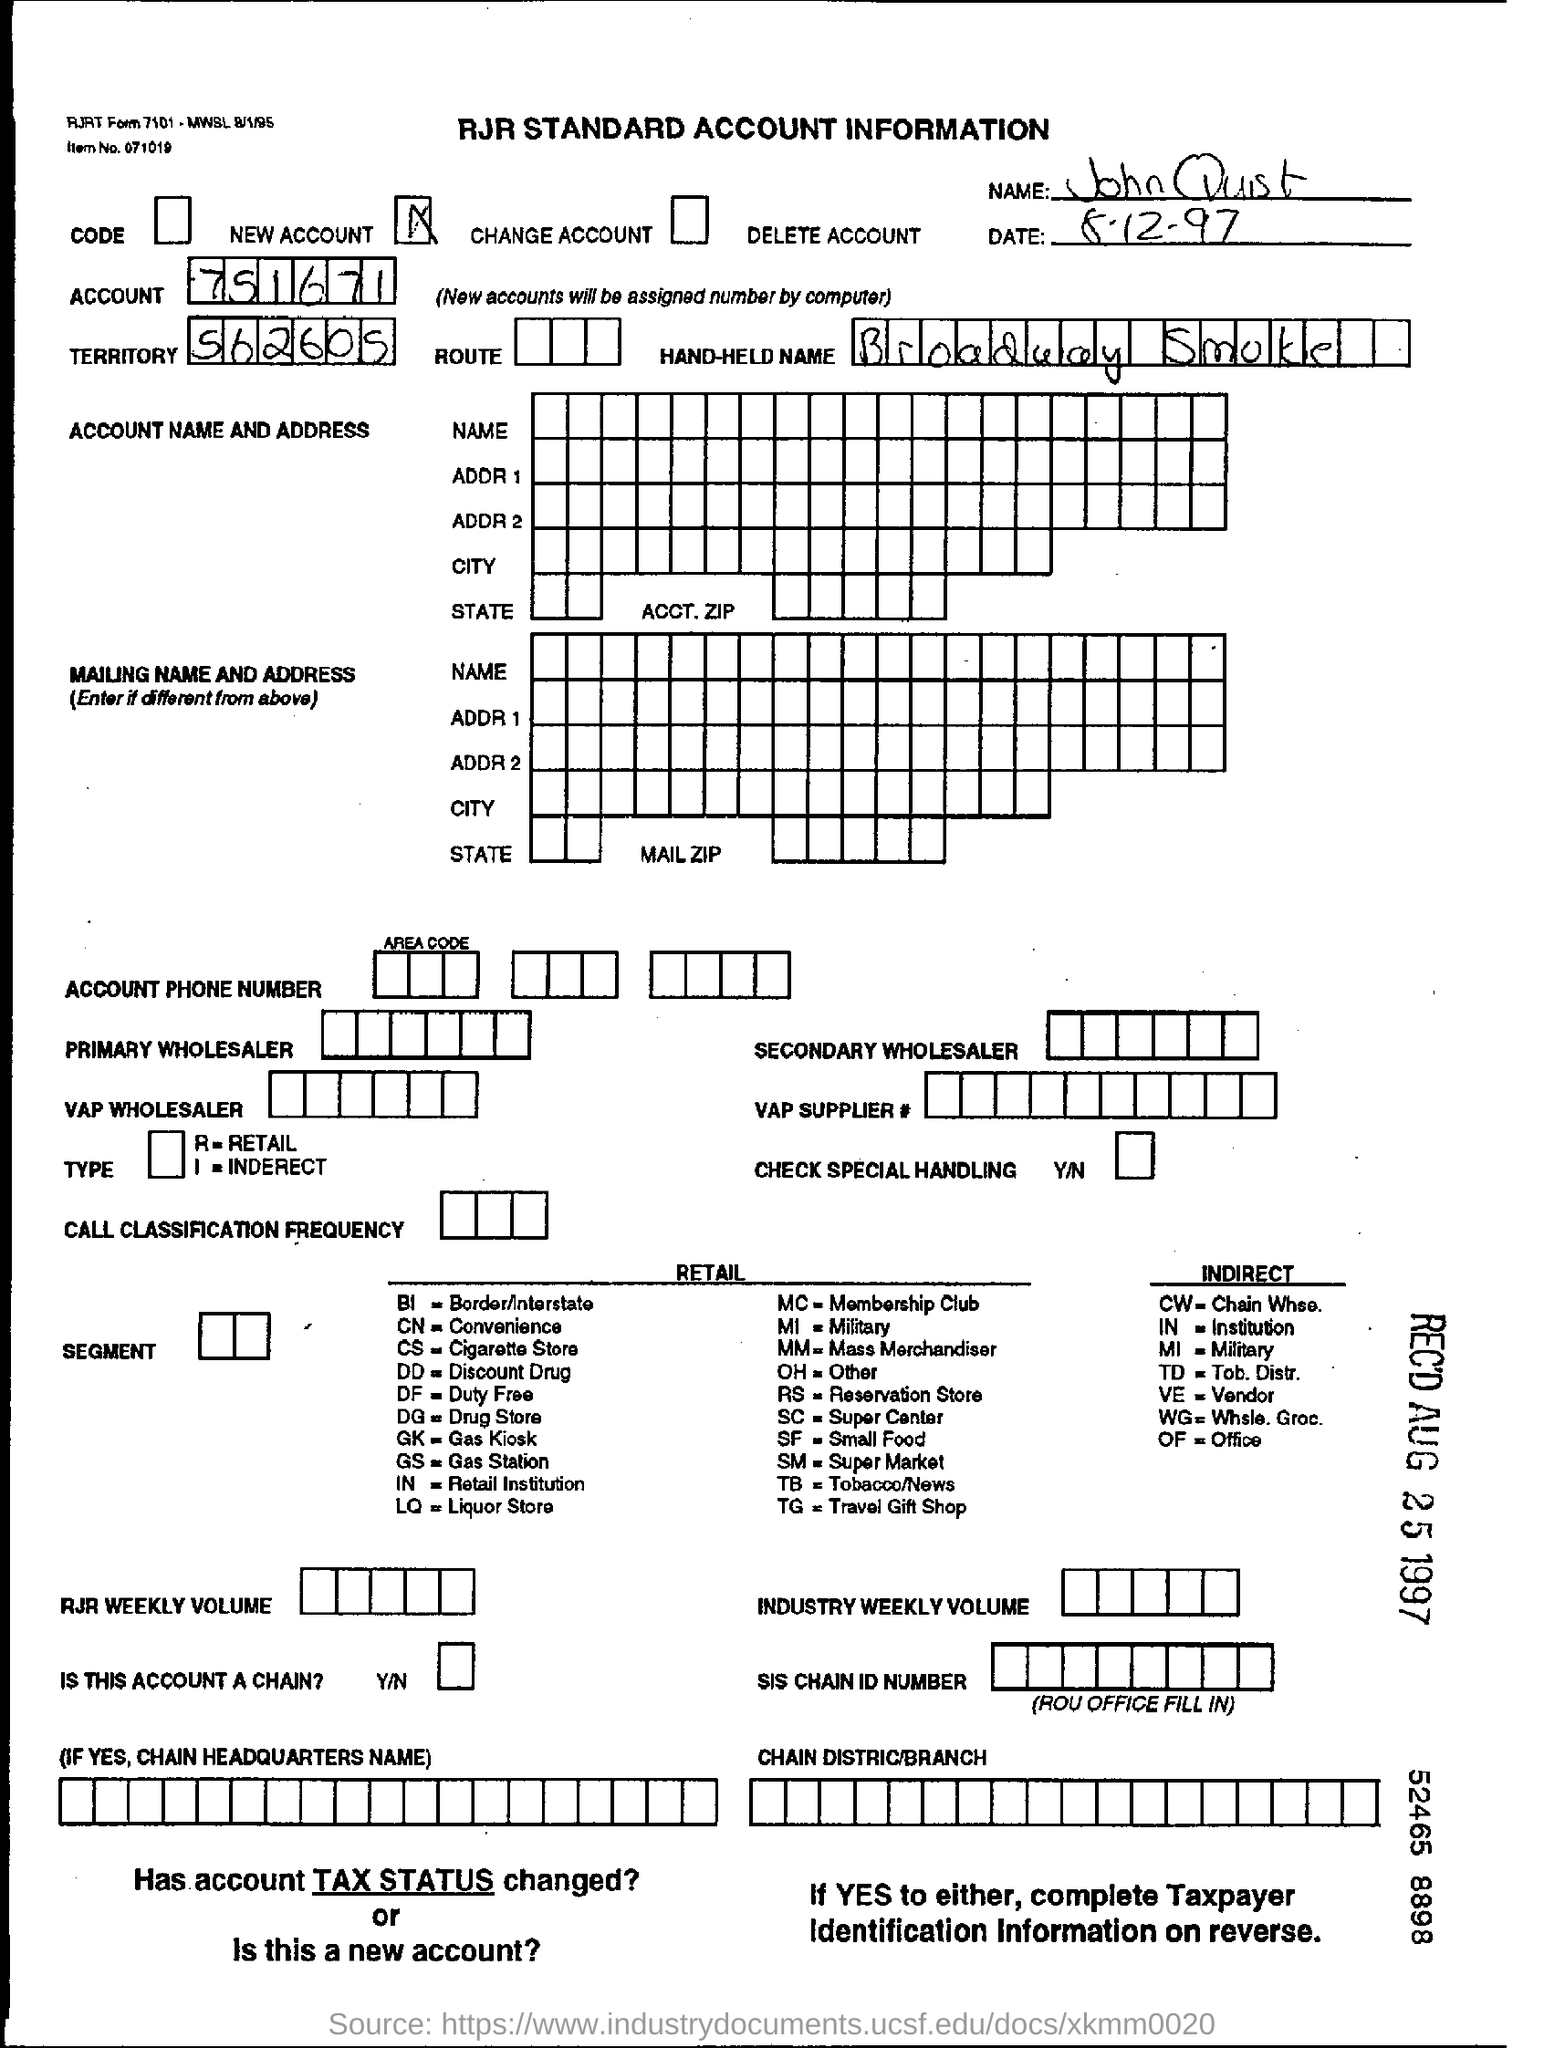What is the name mentioned in the form?
Offer a very short reply. John quist. What is the account no given in the form?
Your answer should be very brief. 751671. What is the Territory no given in the form?
Make the answer very short. 562605. What is the date mentioned in the form?
Provide a succinct answer. 8-12-97. 